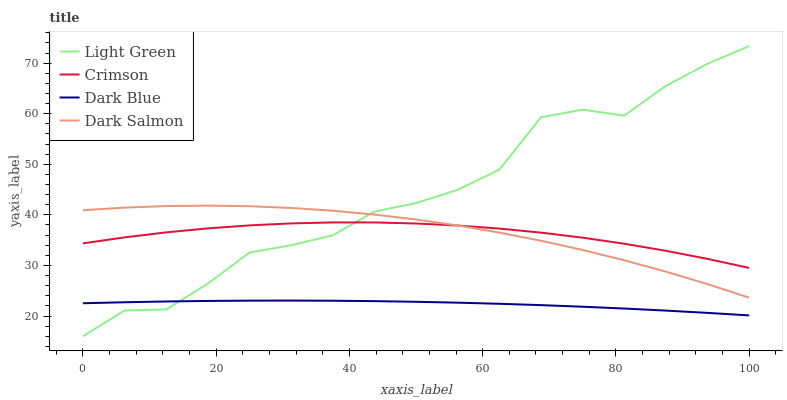Does Dark Blue have the minimum area under the curve?
Answer yes or no. Yes. Does Light Green have the maximum area under the curve?
Answer yes or no. Yes. Does Dark Salmon have the minimum area under the curve?
Answer yes or no. No. Does Dark Salmon have the maximum area under the curve?
Answer yes or no. No. Is Dark Blue the smoothest?
Answer yes or no. Yes. Is Light Green the roughest?
Answer yes or no. Yes. Is Dark Salmon the smoothest?
Answer yes or no. No. Is Dark Salmon the roughest?
Answer yes or no. No. Does Light Green have the lowest value?
Answer yes or no. Yes. Does Dark Blue have the lowest value?
Answer yes or no. No. Does Light Green have the highest value?
Answer yes or no. Yes. Does Dark Salmon have the highest value?
Answer yes or no. No. Is Dark Blue less than Crimson?
Answer yes or no. Yes. Is Crimson greater than Dark Blue?
Answer yes or no. Yes. Does Crimson intersect Dark Salmon?
Answer yes or no. Yes. Is Crimson less than Dark Salmon?
Answer yes or no. No. Is Crimson greater than Dark Salmon?
Answer yes or no. No. Does Dark Blue intersect Crimson?
Answer yes or no. No. 